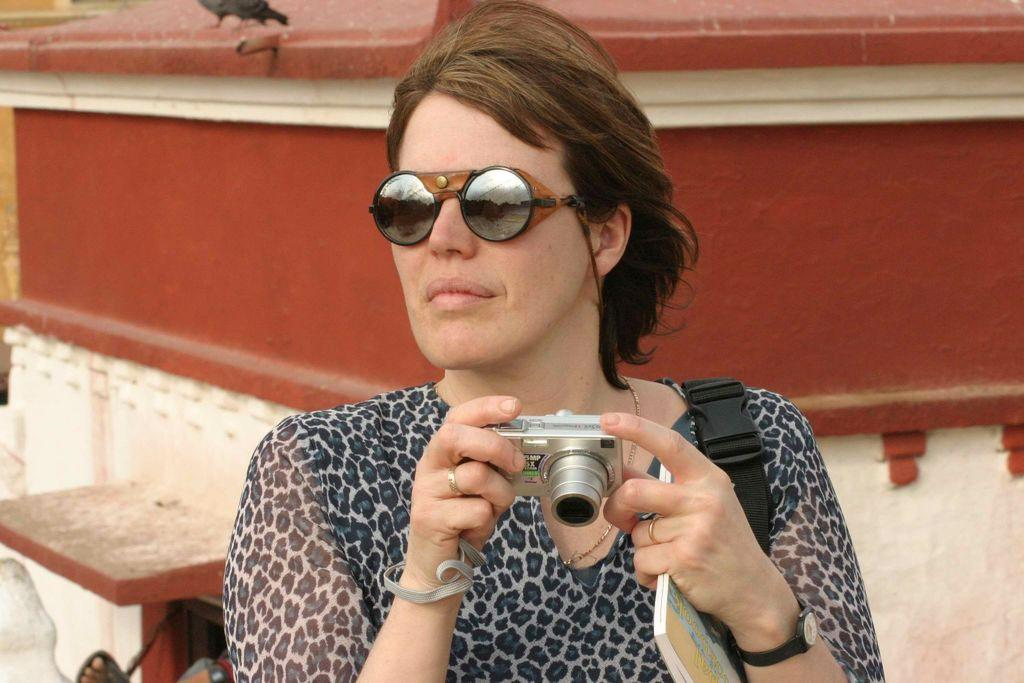Who is the main subject in the image? There is a woman in the image. What is the woman doing in the image? The woman is seated. What is the woman holding in her hand? The woman is holding a camera and a book in her hand. What accessory is the woman wearing in the image? The woman is wearing sunglasses. What type of poisonous grass can be seen in the image? There is no grass, poisonous or otherwise, present in the image. 